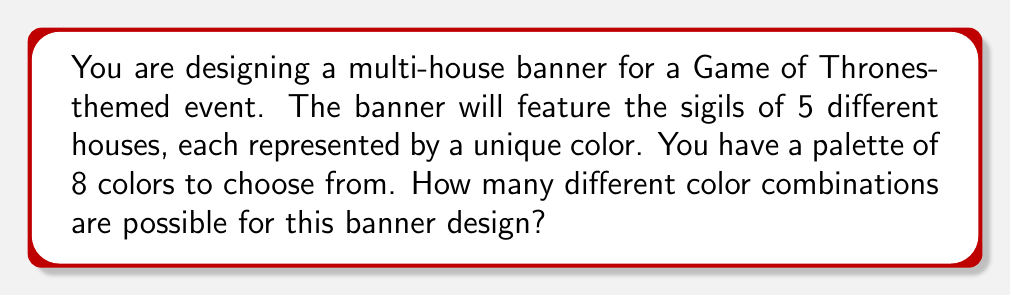Solve this math problem. To solve this problem, we need to use the concept of combinations from Group Theory. We are selecting 5 colors from a set of 8 colors, where the order of selection doesn't matter (as we're just interested in the combination of colors, not their arrangement on the banner).

This scenario is represented by the combination formula:

$${n \choose k} = \frac{n!}{k!(n-k)!}$$

Where:
$n$ is the total number of colors available (8)
$k$ is the number of colors we're selecting (5)

Plugging in our values:

$${8 \choose 5} = \frac{8!}{5!(8-5)!} = \frac{8!}{5!(3)!}$$

Now, let's calculate this step-by-step:

1) $8! = 8 \times 7 \times 6 \times 5 \times 4 \times 3 \times 2 \times 1 = 40,320$
2) $5! = 5 \times 4 \times 3 \times 2 \times 1 = 120$
3) $3! = 3 \times 2 \times 1 = 6$

Substituting these values:

$$\frac{40,320}{120 \times 6} = \frac{40,320}{720} = 56$$

Therefore, there are 56 possible unique color combinations for the multi-house banner design.
Answer: 56 unique color combinations 